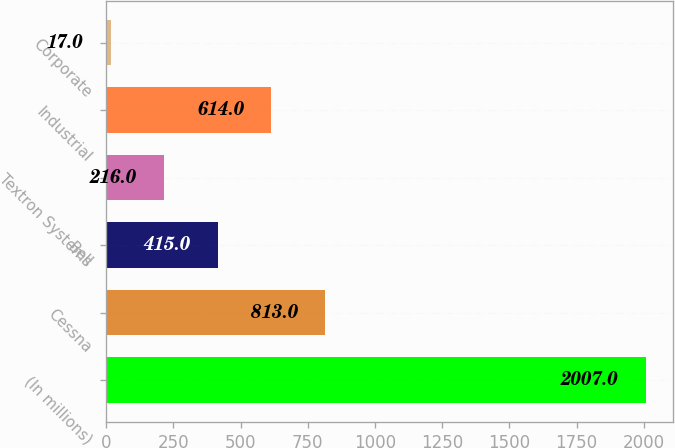<chart> <loc_0><loc_0><loc_500><loc_500><bar_chart><fcel>(In millions)<fcel>Cessna<fcel>Bell<fcel>Textron Systems<fcel>Industrial<fcel>Corporate<nl><fcel>2007<fcel>813<fcel>415<fcel>216<fcel>614<fcel>17<nl></chart> 